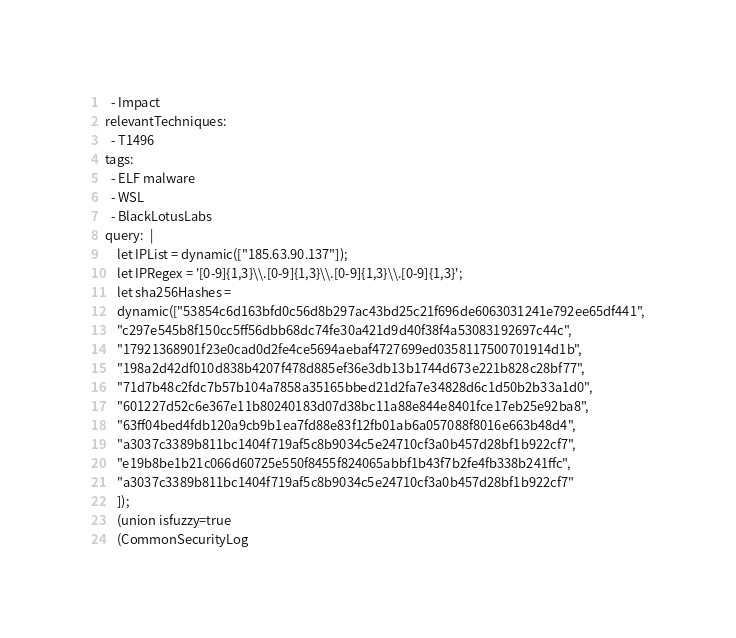Convert code to text. <code><loc_0><loc_0><loc_500><loc_500><_YAML_>  - Impact
relevantTechniques:
  - T1496
tags:
  - ELF malware
  - WSL 
  - BlackLotusLabs
query:  |  
    let IPList = dynamic(["185.63.90.137"]);  
    let IPRegex = '[0-9]{1,3}\\.[0-9]{1,3}\\.[0-9]{1,3}\\.[0-9]{1,3}';
    let sha256Hashes = 
    dynamic(["53854c6d163bfd0c56d8b297ac43bd25c21f696de6063031241e792ee65df441",
    "c297e545b8f150cc5ff56dbb68dc74fe30a421d9d40f38f4a53083192697c44c",
    "17921368901f23e0cad0d2fe4ce5694aebaf4727699ed0358117500701914d1b",
    "198a2d42df010d838b4207f478d885ef36e3db13b1744d673e221b828c28bf77",
    "71d7b48c2fdc7b57b104a7858a35165bbed21d2fa7e34828d6c1d50b2b33a1d0",
    "601227d52c6e367e11b80240183d07d38bc11a88e844e8401fce17eb25e92ba8",
    "63ff04bed4fdb120a9cb9b1ea7fd88e83f12fb01ab6a057088f8016e663b48d4",
    "a3037c3389b811bc1404f719af5c8b9034c5e24710cf3a0b457d28bf1b922cf7",
    "e19b8be1b21c066d60725e550f8455f824065abbf1b43f7b2fe4fb338b241ffc",
    "a3037c3389b811bc1404f719af5c8b9034c5e24710cf3a0b457d28bf1b922cf7"
    ]);
    (union isfuzzy=true
    (CommonSecurityLog</code> 